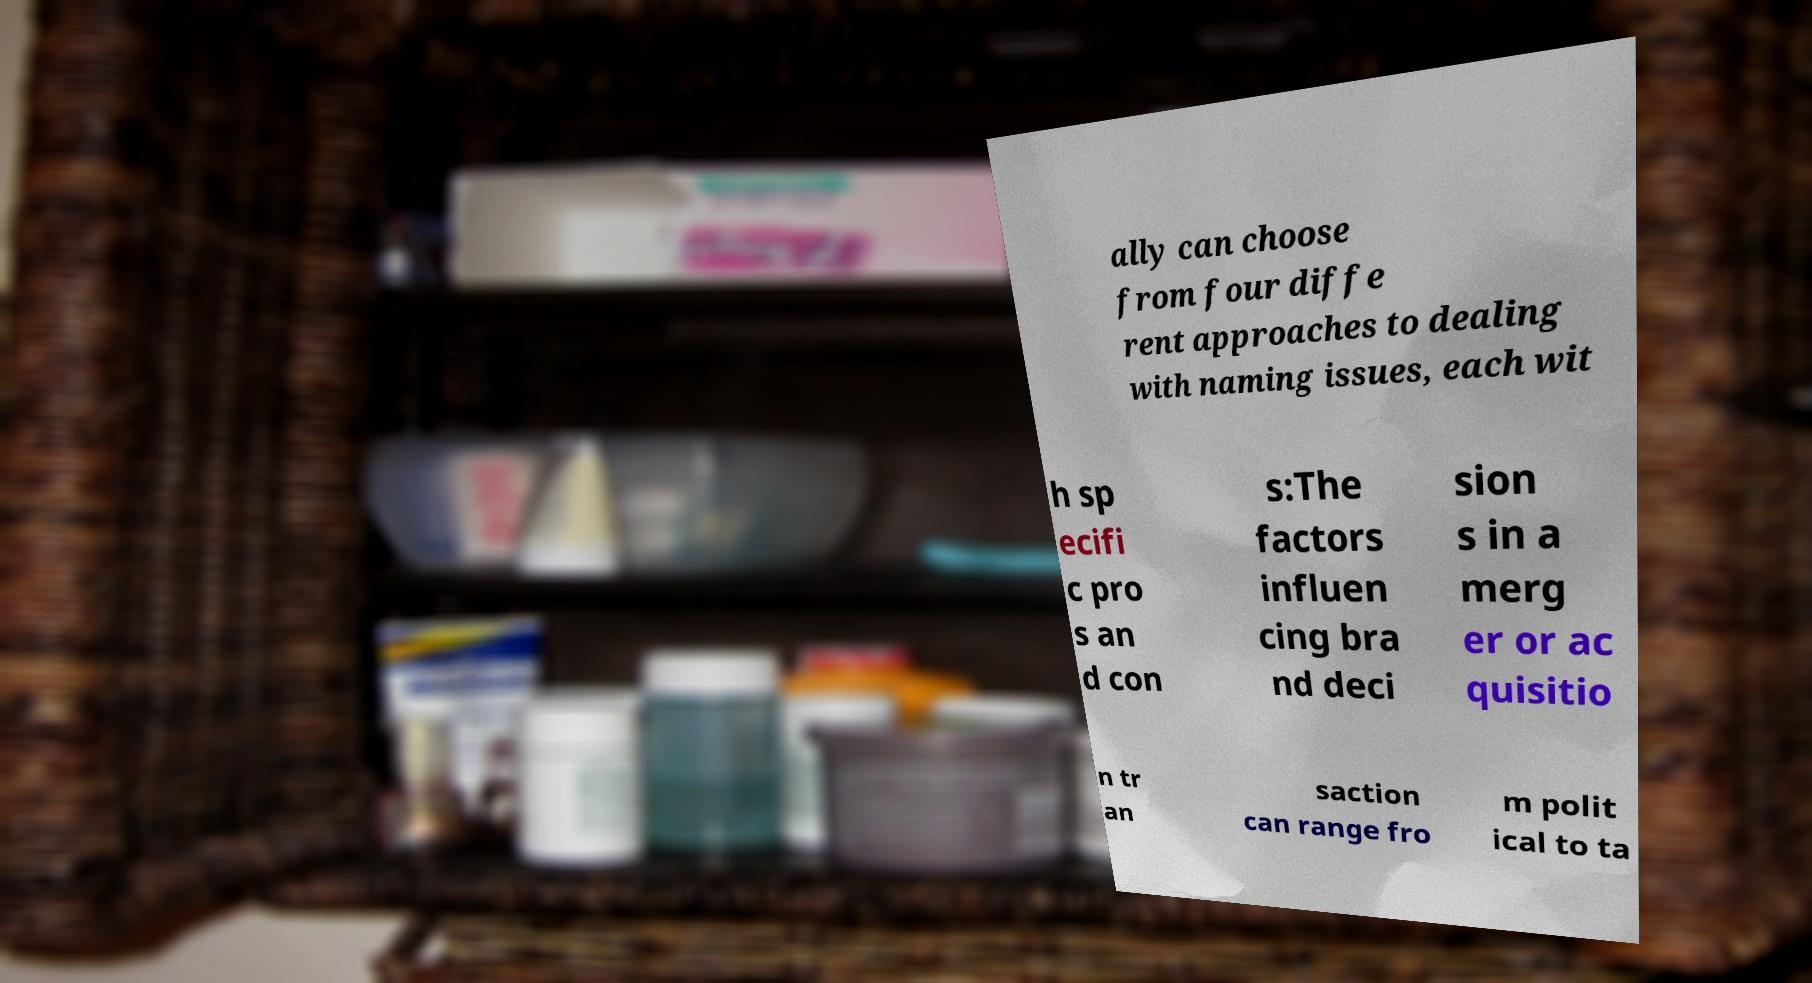Can you accurately transcribe the text from the provided image for me? ally can choose from four diffe rent approaches to dealing with naming issues, each wit h sp ecifi c pro s an d con s:The factors influen cing bra nd deci sion s in a merg er or ac quisitio n tr an saction can range fro m polit ical to ta 